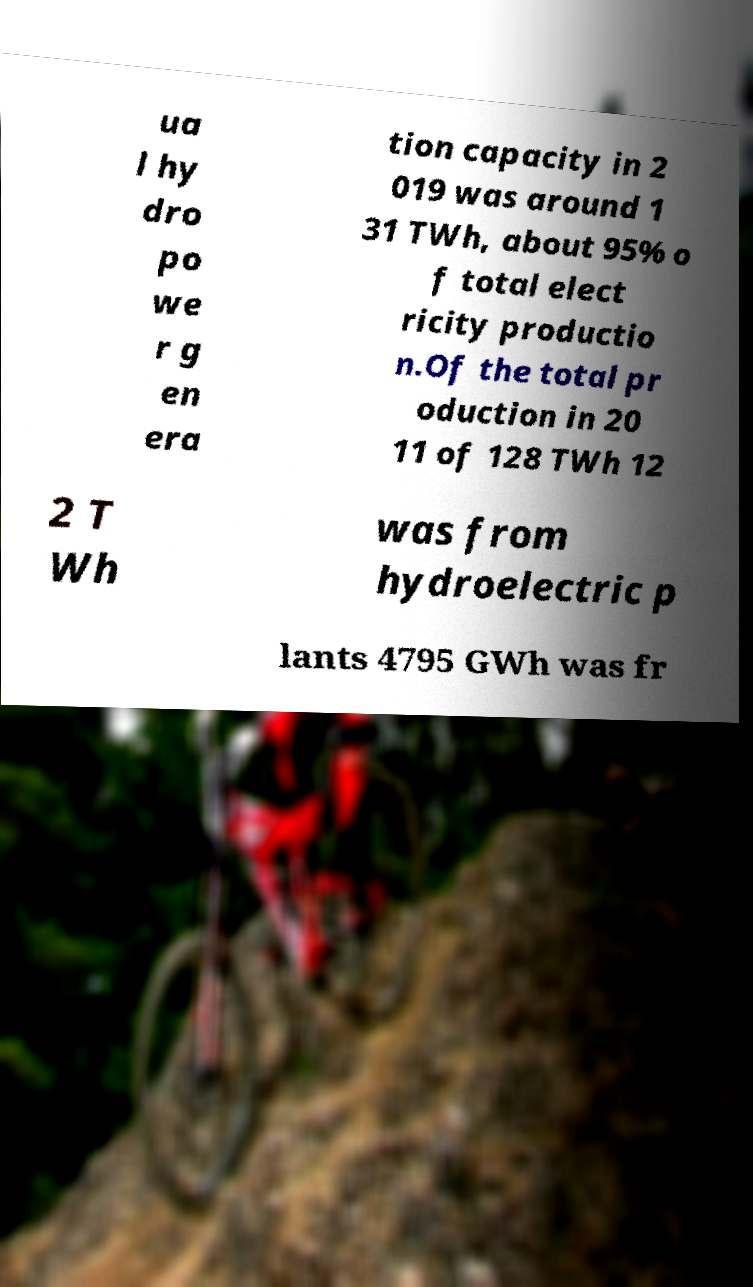Could you extract and type out the text from this image? ua l hy dro po we r g en era tion capacity in 2 019 was around 1 31 TWh, about 95% o f total elect ricity productio n.Of the total pr oduction in 20 11 of 128 TWh 12 2 T Wh was from hydroelectric p lants 4795 GWh was fr 